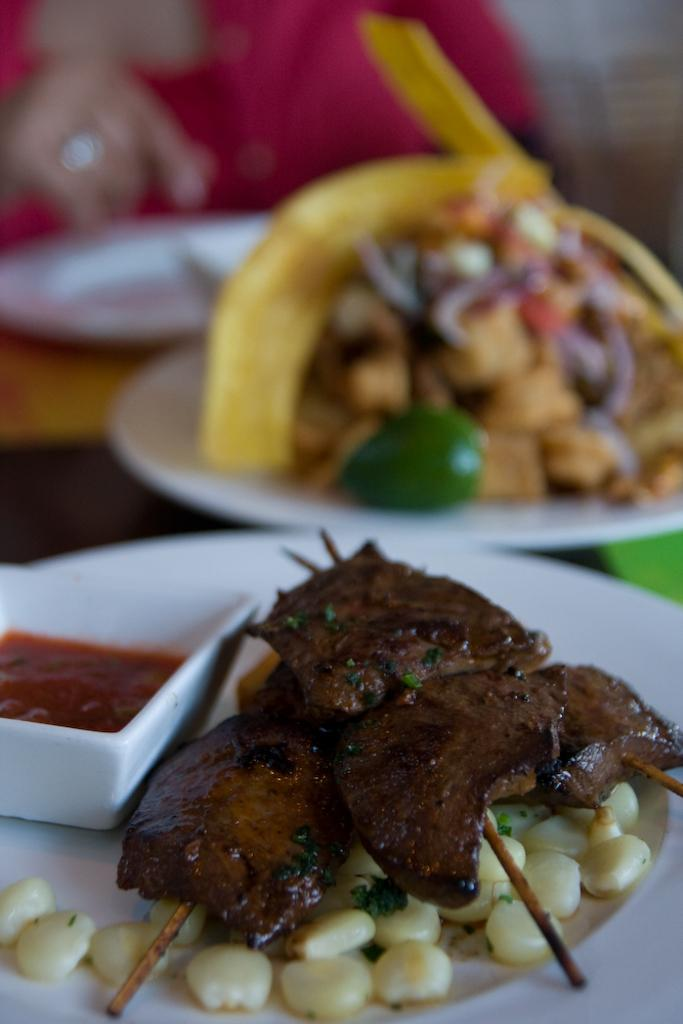What type of dishware can be seen in the image? There are plates and a bowl in the image. What is the food placed on in the image? The food is placed on a platform in the image. Can you describe the presence of a person in the image? There is a person visible in the background of the image. What type of texture can be seen on the person's hair in the image? There is no person's hair visible in the image; only a person in the background is mentioned. Can you describe the person's combing technique in the image? There is no comb or any indication of hair grooming in the image. 